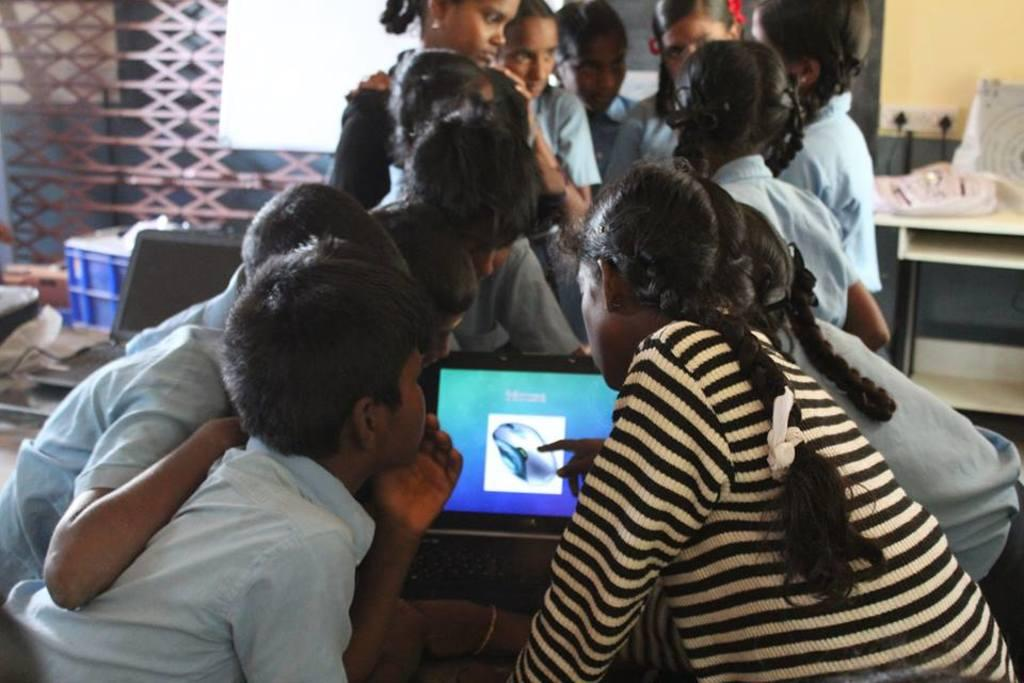Who is present in the image? There are children in the image. What are the children doing in the image? The children are around a computer. Can you describe the gender of the children in the image? There are both boys and girls in the image. What can be seen on the right side of the image? There is a yellow color wall on the right side of the image. What furniture is present in the image? There is a table in the image. What type of whistle can be heard in the image? There is no whistle present in the image, and therefore no sound can be heard. 